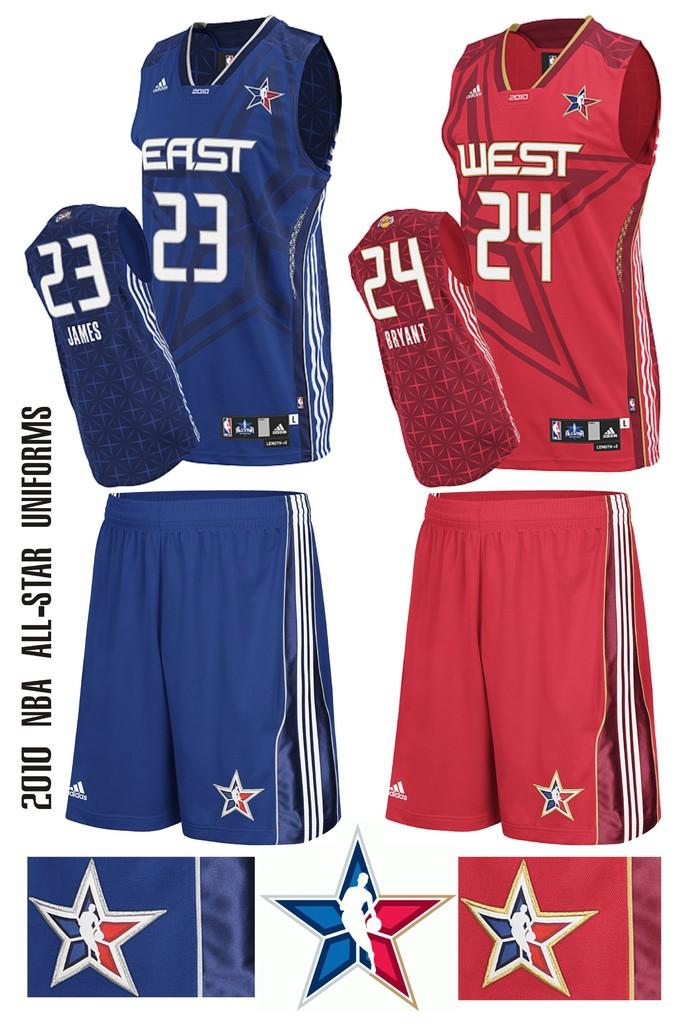<image>
Describe the image concisely. Jerseys for the East and West all stars are being advertised. 